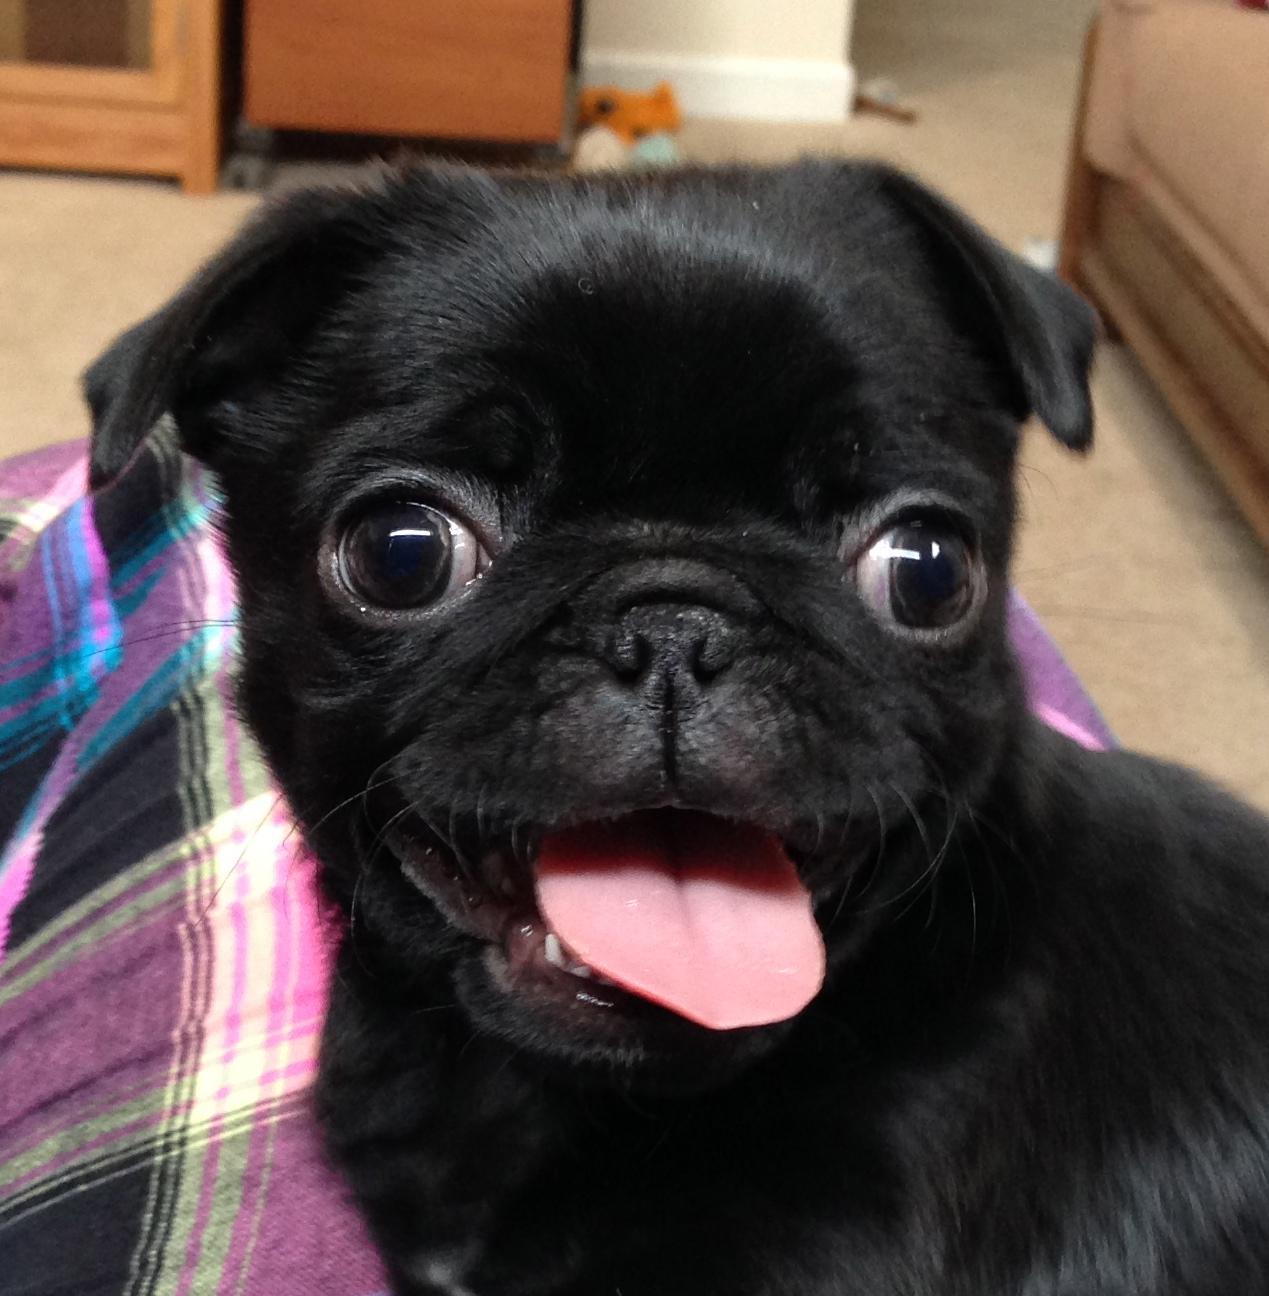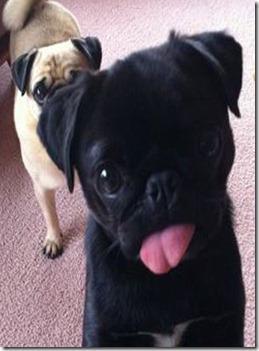The first image is the image on the left, the second image is the image on the right. Evaluate the accuracy of this statement regarding the images: "At least one of the dogs is wearing something around its neck.". Is it true? Answer yes or no. No. 